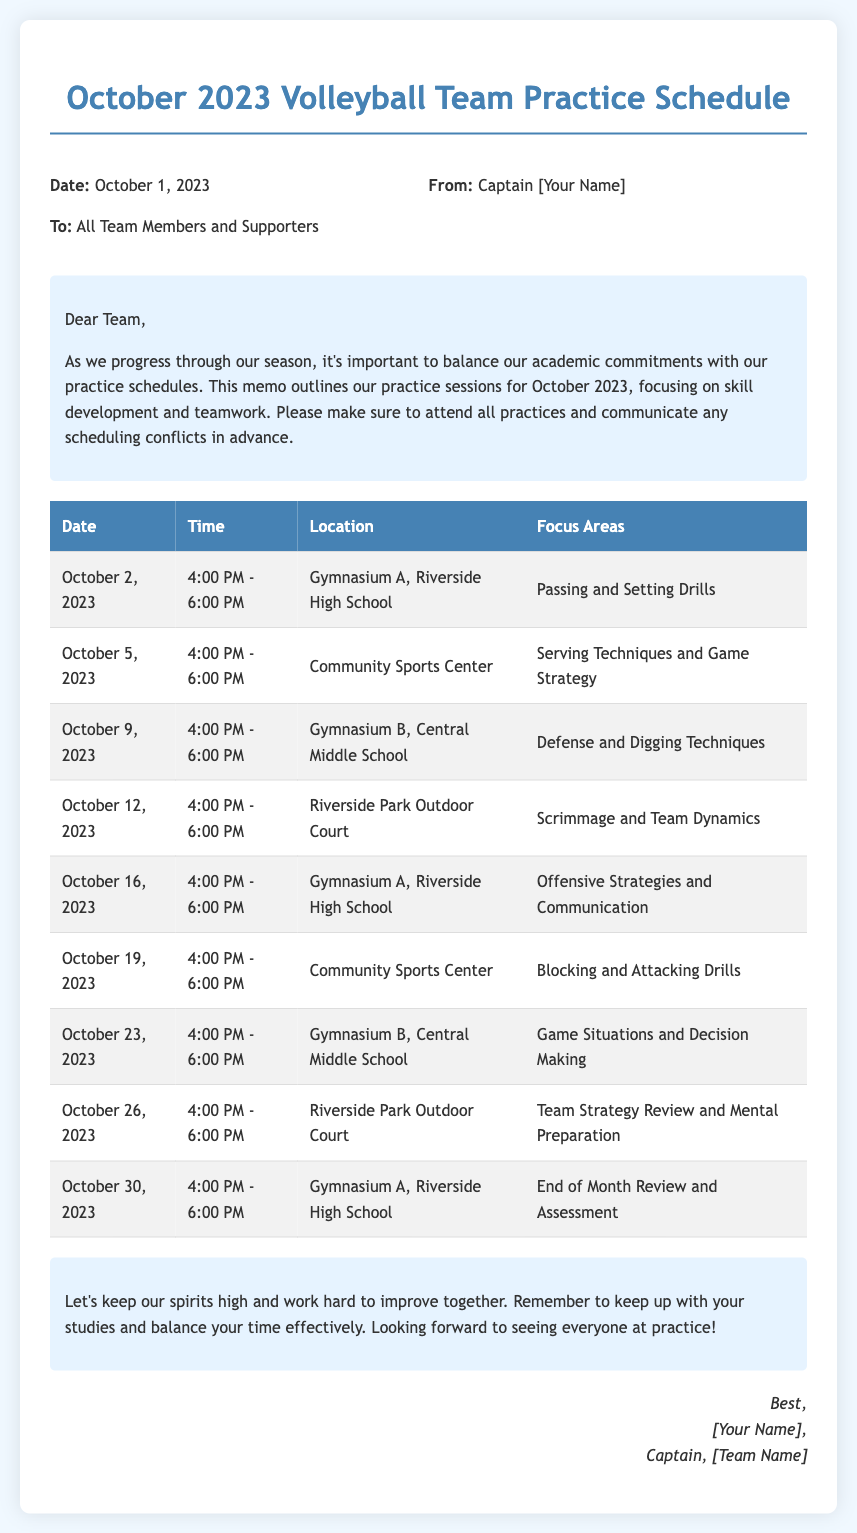what is the date of the first practice? The first practice is scheduled for October 2, 2023, as indicated in the document.
Answer: October 2, 2023 how long is each practice session? Each practice session is from 4:00 PM to 6:00 PM, which is a duration of two hours.
Answer: 2 hours where will the practice on October 5th take place? The practice on October 5, 2023, will take place at the Community Sports Center, as mentioned in the schedule.
Answer: Community Sports Center what is one focus area for the practice on October 12th? The practice on October 12, 2023, focuses on Scrimmage and Team Dynamics, as noted in the schedule.
Answer: Scrimmage and Team Dynamics how many practice sessions are scheduled for October? There are a total of 9 practice sessions scheduled for October 2023, based on the table provided.
Answer: 9 